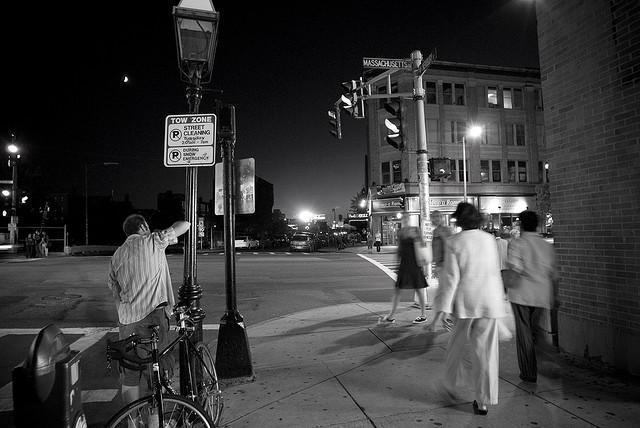How many people are in the picture?
Give a very brief answer. 5. How many people are in the photo?
Give a very brief answer. 4. How many bicycles are there?
Give a very brief answer. 2. 